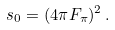<formula> <loc_0><loc_0><loc_500><loc_500>s _ { 0 } = ( 4 \pi F _ { \pi } ) ^ { 2 } \, .</formula> 